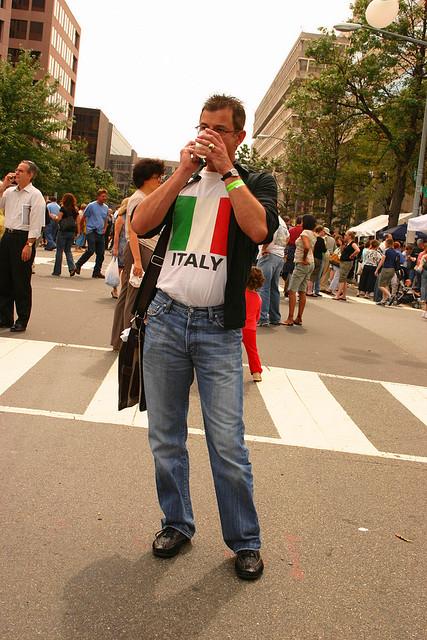What flag can be seen in the picture?
Be succinct. Italy. Is the man in the foreground standing on a crosswalk?
Quick response, please. No. What color is the man's bracelet?
Short answer required. Green. Is the suitcase being carried?
Answer briefly. Yes. Do you think this guy is Italian?
Answer briefly. Yes. 